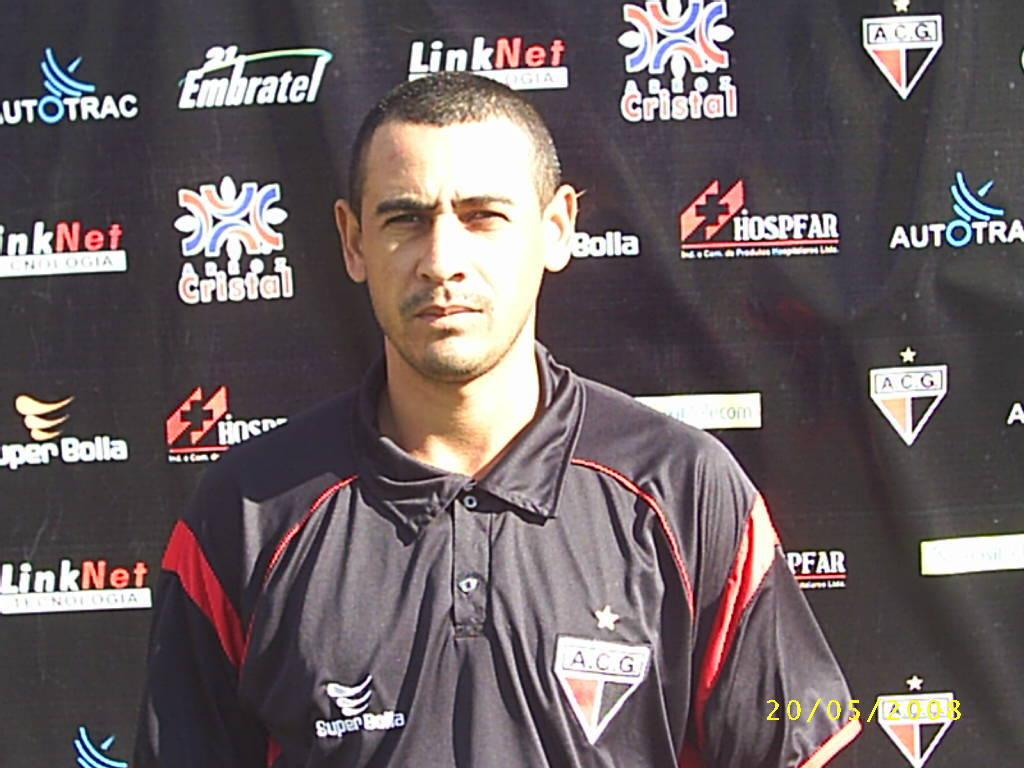Provide a one-sentence caption for the provided image. Man wearing a Super Bolta polo in front of a black background. 